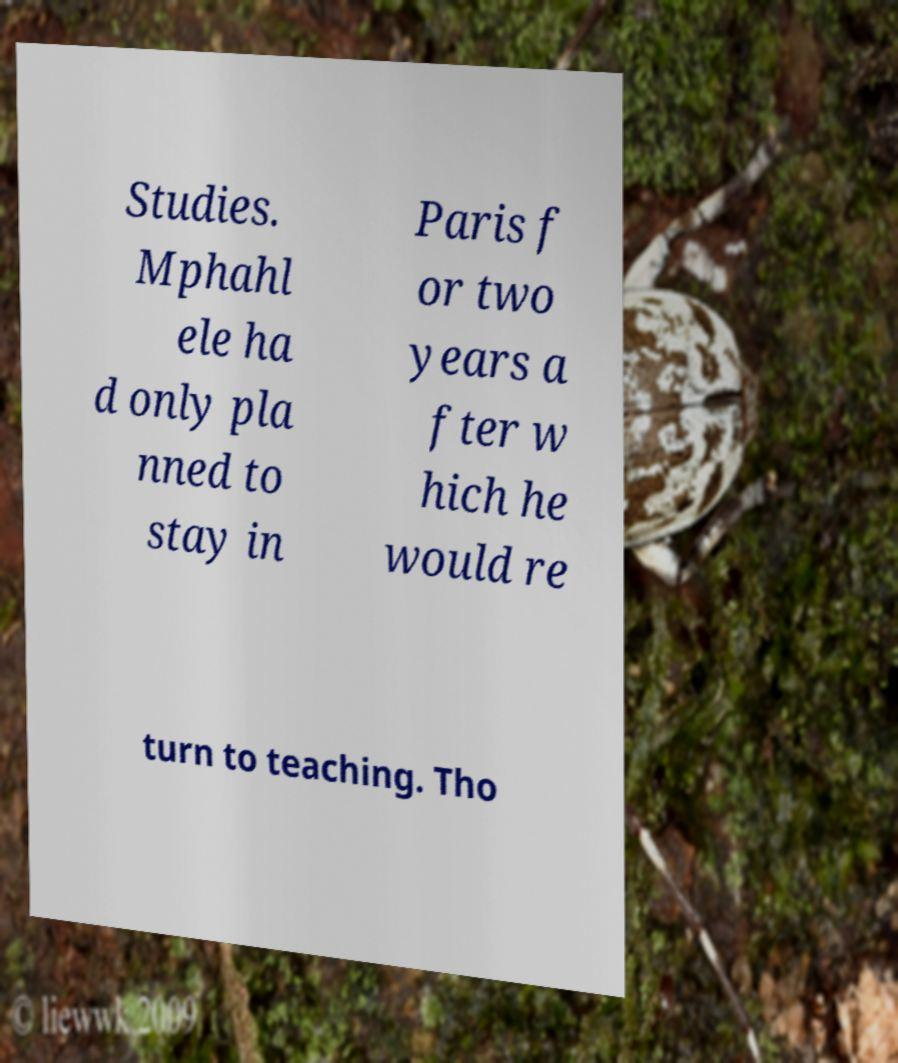Please identify and transcribe the text found in this image. Studies. Mphahl ele ha d only pla nned to stay in Paris f or two years a fter w hich he would re turn to teaching. Tho 